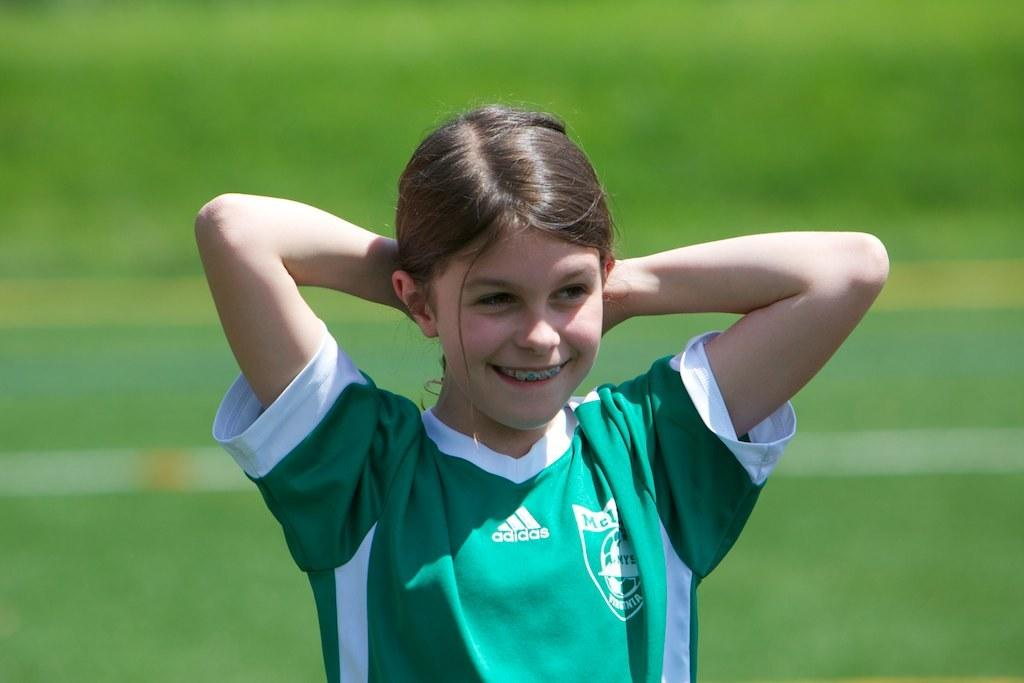Provide a one-sentence caption for the provided image. A picture of a younger girl playing soccor, on the field, wearing her team jersey who is sponsered by Adidas. 